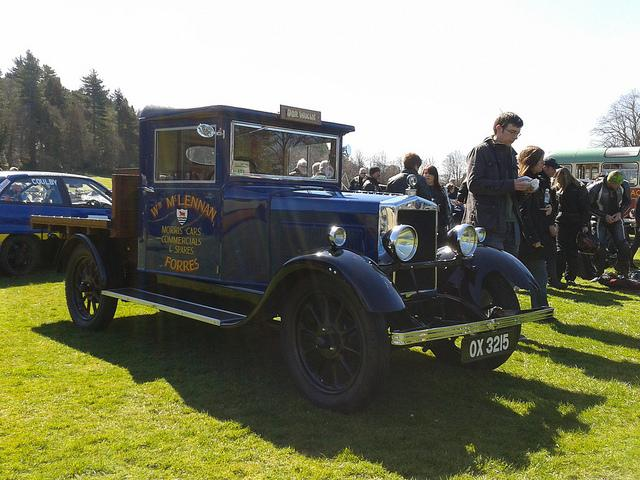What type of truck is shown?

Choices:
A) moving
B) garbage
C) commercial
D) antique antique 